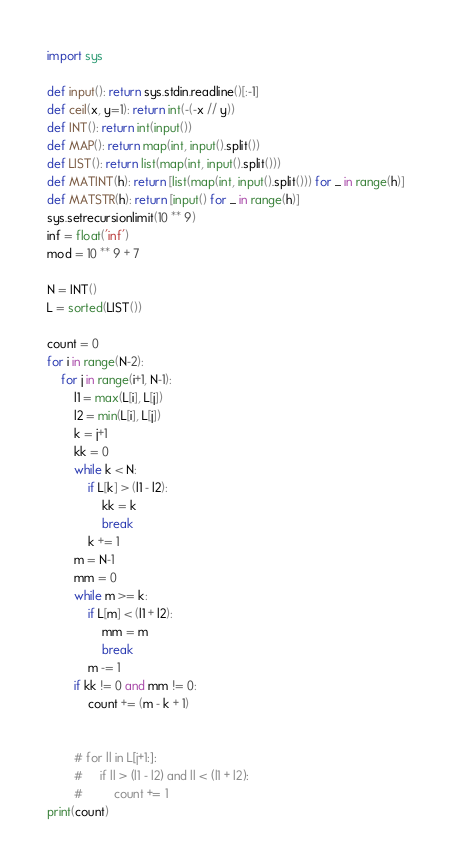<code> <loc_0><loc_0><loc_500><loc_500><_Python_>import sys

def input(): return sys.stdin.readline()[:-1]
def ceil(x, y=1): return int(-(-x // y))
def INT(): return int(input())
def MAP(): return map(int, input().split())
def LIST(): return list(map(int, input().split()))
def MATINT(h): return [list(map(int, input().split())) for _ in range(h)]
def MATSTR(h): return [input() for _ in range(h)]
sys.setrecursionlimit(10 ** 9)
inf = float('inf')
mod = 10 ** 9 + 7

N = INT()
L = sorted(LIST())

count = 0
for i in range(N-2):
    for j in range(i+1, N-1):
        l1 = max(L[i], L[j])
        l2 = min(L[i], L[j])
        k = j+1
        kk = 0
        while k < N:
            if L[k] > (l1 - l2):
                kk = k
                break
            k += 1
        m = N-1
        mm = 0
        while m >= k:
            if L[m] < (l1 + l2):
                mm = m
                break
            m -= 1
        if kk != 0 and mm != 0:
            count += (m - k + 1)


        # for ll in L[j+1:]:
        #     if ll > (l1 - l2) and ll < (l1 + l2):
        #         count += 1
print(count)
</code> 